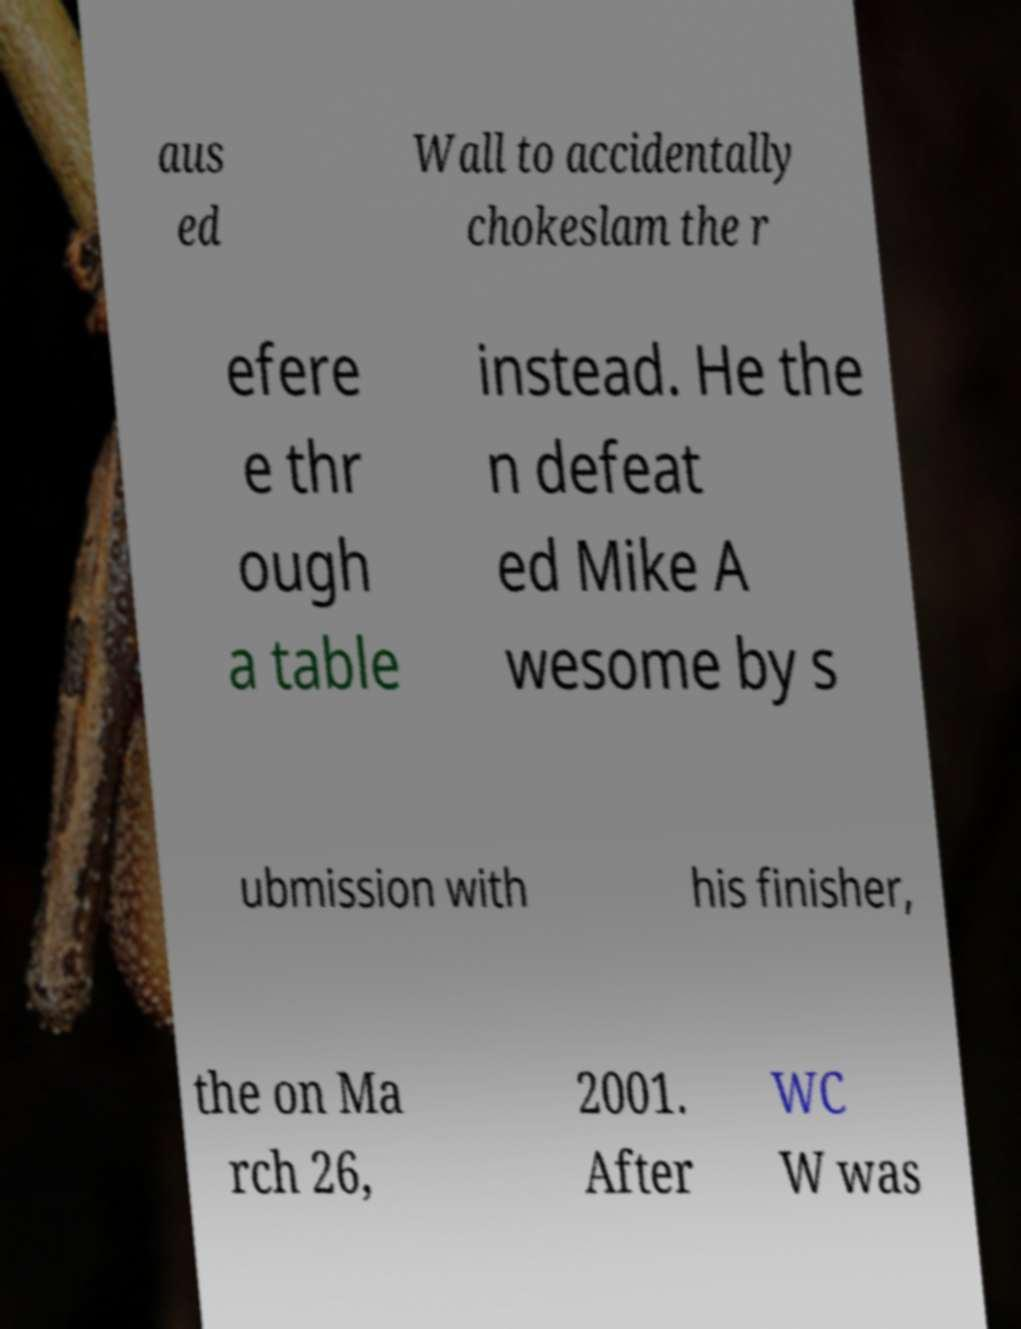Could you extract and type out the text from this image? aus ed Wall to accidentally chokeslam the r efere e thr ough a table instead. He the n defeat ed Mike A wesome by s ubmission with his finisher, the on Ma rch 26, 2001. After WC W was 